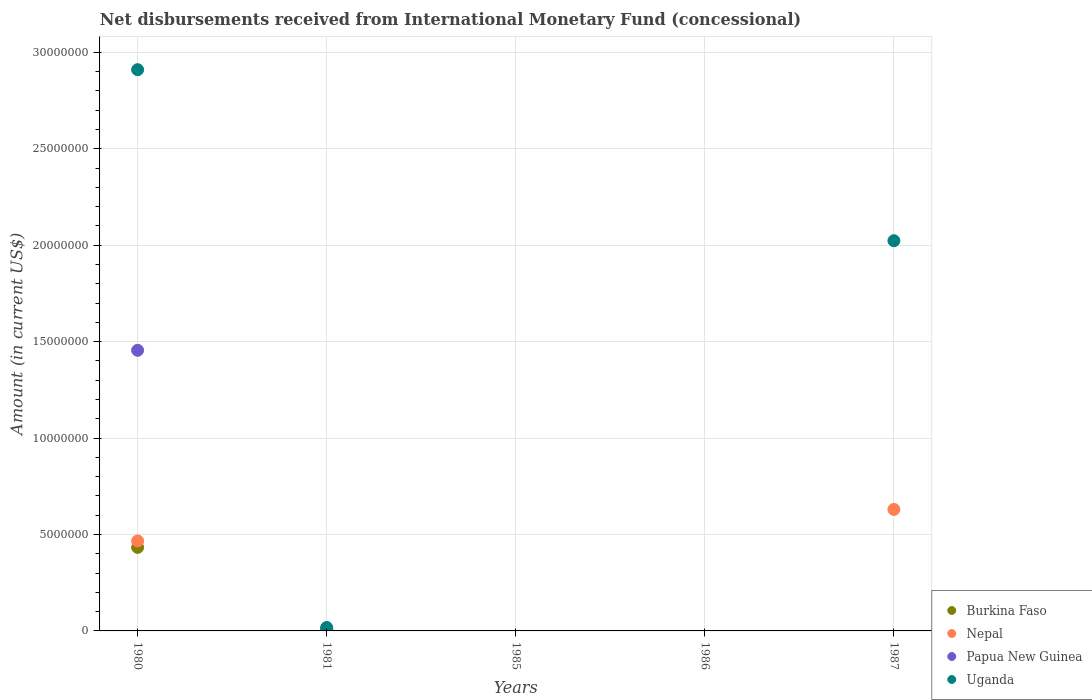Is the number of dotlines equal to the number of legend labels?
Offer a very short reply. No. What is the amount of disbursements received from International Monetary Fund in Uganda in 1981?
Your answer should be very brief. 1.78e+05. Across all years, what is the maximum amount of disbursements received from International Monetary Fund in Uganda?
Offer a very short reply. 2.91e+07. Across all years, what is the minimum amount of disbursements received from International Monetary Fund in Papua New Guinea?
Your answer should be very brief. 0. What is the total amount of disbursements received from International Monetary Fund in Nepal in the graph?
Provide a short and direct response. 1.10e+07. What is the difference between the amount of disbursements received from International Monetary Fund in Papua New Guinea in 1980 and that in 1981?
Offer a very short reply. 1.45e+07. What is the difference between the amount of disbursements received from International Monetary Fund in Papua New Guinea in 1986 and the amount of disbursements received from International Monetary Fund in Nepal in 1987?
Make the answer very short. -6.30e+06. What is the average amount of disbursements received from International Monetary Fund in Burkina Faso per year?
Offer a terse response. 8.78e+05. In the year 1981, what is the difference between the amount of disbursements received from International Monetary Fund in Burkina Faso and amount of disbursements received from International Monetary Fund in Papua New Guinea?
Offer a very short reply. -3.20e+04. What is the ratio of the amount of disbursements received from International Monetary Fund in Nepal in 1980 to that in 1987?
Offer a terse response. 0.74. Is the amount of disbursements received from International Monetary Fund in Uganda in 1980 less than that in 1981?
Ensure brevity in your answer.  No. What is the difference between the highest and the second highest amount of disbursements received from International Monetary Fund in Uganda?
Make the answer very short. 8.87e+06. What is the difference between the highest and the lowest amount of disbursements received from International Monetary Fund in Nepal?
Your response must be concise. 6.30e+06. Is it the case that in every year, the sum of the amount of disbursements received from International Monetary Fund in Nepal and amount of disbursements received from International Monetary Fund in Uganda  is greater than the sum of amount of disbursements received from International Monetary Fund in Burkina Faso and amount of disbursements received from International Monetary Fund in Papua New Guinea?
Your answer should be very brief. No. Does the amount of disbursements received from International Monetary Fund in Nepal monotonically increase over the years?
Your answer should be compact. No. Is the amount of disbursements received from International Monetary Fund in Papua New Guinea strictly greater than the amount of disbursements received from International Monetary Fund in Uganda over the years?
Offer a very short reply. No. Is the amount of disbursements received from International Monetary Fund in Papua New Guinea strictly less than the amount of disbursements received from International Monetary Fund in Nepal over the years?
Make the answer very short. No. How many years are there in the graph?
Offer a very short reply. 5. What is the difference between two consecutive major ticks on the Y-axis?
Provide a succinct answer. 5.00e+06. Does the graph contain any zero values?
Give a very brief answer. Yes. How are the legend labels stacked?
Your answer should be compact. Vertical. What is the title of the graph?
Provide a short and direct response. Net disbursements received from International Monetary Fund (concessional). Does "Cyprus" appear as one of the legend labels in the graph?
Ensure brevity in your answer.  No. What is the label or title of the X-axis?
Provide a short and direct response. Years. What is the Amount (in current US$) in Burkina Faso in 1980?
Offer a very short reply. 4.33e+06. What is the Amount (in current US$) in Nepal in 1980?
Keep it short and to the point. 4.66e+06. What is the Amount (in current US$) in Papua New Guinea in 1980?
Provide a succinct answer. 1.46e+07. What is the Amount (in current US$) of Uganda in 1980?
Offer a very short reply. 2.91e+07. What is the Amount (in current US$) of Burkina Faso in 1981?
Keep it short and to the point. 5.80e+04. What is the Amount (in current US$) of Nepal in 1981?
Your answer should be very brief. 6.30e+04. What is the Amount (in current US$) in Uganda in 1981?
Your answer should be compact. 1.78e+05. What is the Amount (in current US$) of Burkina Faso in 1985?
Your answer should be very brief. 0. What is the Amount (in current US$) in Nepal in 1985?
Your answer should be very brief. 0. What is the Amount (in current US$) of Papua New Guinea in 1985?
Offer a terse response. 0. What is the Amount (in current US$) in Burkina Faso in 1986?
Your answer should be compact. 0. What is the Amount (in current US$) of Nepal in 1986?
Keep it short and to the point. 0. What is the Amount (in current US$) of Nepal in 1987?
Give a very brief answer. 6.30e+06. What is the Amount (in current US$) of Papua New Guinea in 1987?
Your answer should be very brief. 0. What is the Amount (in current US$) in Uganda in 1987?
Keep it short and to the point. 2.02e+07. Across all years, what is the maximum Amount (in current US$) of Burkina Faso?
Offer a very short reply. 4.33e+06. Across all years, what is the maximum Amount (in current US$) in Nepal?
Offer a very short reply. 6.30e+06. Across all years, what is the maximum Amount (in current US$) in Papua New Guinea?
Your answer should be very brief. 1.46e+07. Across all years, what is the maximum Amount (in current US$) of Uganda?
Your response must be concise. 2.91e+07. Across all years, what is the minimum Amount (in current US$) of Burkina Faso?
Keep it short and to the point. 0. Across all years, what is the minimum Amount (in current US$) in Nepal?
Your response must be concise. 0. What is the total Amount (in current US$) in Burkina Faso in the graph?
Keep it short and to the point. 4.39e+06. What is the total Amount (in current US$) in Nepal in the graph?
Provide a short and direct response. 1.10e+07. What is the total Amount (in current US$) of Papua New Guinea in the graph?
Give a very brief answer. 1.46e+07. What is the total Amount (in current US$) of Uganda in the graph?
Offer a terse response. 4.95e+07. What is the difference between the Amount (in current US$) in Burkina Faso in 1980 and that in 1981?
Make the answer very short. 4.27e+06. What is the difference between the Amount (in current US$) in Nepal in 1980 and that in 1981?
Make the answer very short. 4.60e+06. What is the difference between the Amount (in current US$) in Papua New Guinea in 1980 and that in 1981?
Make the answer very short. 1.45e+07. What is the difference between the Amount (in current US$) of Uganda in 1980 and that in 1981?
Give a very brief answer. 2.89e+07. What is the difference between the Amount (in current US$) in Nepal in 1980 and that in 1987?
Provide a short and direct response. -1.64e+06. What is the difference between the Amount (in current US$) of Uganda in 1980 and that in 1987?
Provide a short and direct response. 8.87e+06. What is the difference between the Amount (in current US$) of Nepal in 1981 and that in 1987?
Keep it short and to the point. -6.24e+06. What is the difference between the Amount (in current US$) of Uganda in 1981 and that in 1987?
Offer a very short reply. -2.01e+07. What is the difference between the Amount (in current US$) of Burkina Faso in 1980 and the Amount (in current US$) of Nepal in 1981?
Make the answer very short. 4.27e+06. What is the difference between the Amount (in current US$) in Burkina Faso in 1980 and the Amount (in current US$) in Papua New Guinea in 1981?
Provide a succinct answer. 4.24e+06. What is the difference between the Amount (in current US$) in Burkina Faso in 1980 and the Amount (in current US$) in Uganda in 1981?
Offer a very short reply. 4.15e+06. What is the difference between the Amount (in current US$) in Nepal in 1980 and the Amount (in current US$) in Papua New Guinea in 1981?
Make the answer very short. 4.58e+06. What is the difference between the Amount (in current US$) in Nepal in 1980 and the Amount (in current US$) in Uganda in 1981?
Your response must be concise. 4.49e+06. What is the difference between the Amount (in current US$) in Papua New Guinea in 1980 and the Amount (in current US$) in Uganda in 1981?
Provide a short and direct response. 1.44e+07. What is the difference between the Amount (in current US$) in Burkina Faso in 1980 and the Amount (in current US$) in Nepal in 1987?
Make the answer very short. -1.97e+06. What is the difference between the Amount (in current US$) in Burkina Faso in 1980 and the Amount (in current US$) in Uganda in 1987?
Offer a terse response. -1.59e+07. What is the difference between the Amount (in current US$) in Nepal in 1980 and the Amount (in current US$) in Uganda in 1987?
Ensure brevity in your answer.  -1.56e+07. What is the difference between the Amount (in current US$) in Papua New Guinea in 1980 and the Amount (in current US$) in Uganda in 1987?
Offer a very short reply. -5.68e+06. What is the difference between the Amount (in current US$) in Burkina Faso in 1981 and the Amount (in current US$) in Nepal in 1987?
Your answer should be very brief. -6.24e+06. What is the difference between the Amount (in current US$) of Burkina Faso in 1981 and the Amount (in current US$) of Uganda in 1987?
Give a very brief answer. -2.02e+07. What is the difference between the Amount (in current US$) of Nepal in 1981 and the Amount (in current US$) of Uganda in 1987?
Offer a terse response. -2.02e+07. What is the difference between the Amount (in current US$) in Papua New Guinea in 1981 and the Amount (in current US$) in Uganda in 1987?
Offer a very short reply. -2.01e+07. What is the average Amount (in current US$) of Burkina Faso per year?
Your response must be concise. 8.78e+05. What is the average Amount (in current US$) in Nepal per year?
Ensure brevity in your answer.  2.21e+06. What is the average Amount (in current US$) of Papua New Guinea per year?
Make the answer very short. 2.93e+06. What is the average Amount (in current US$) in Uganda per year?
Keep it short and to the point. 9.90e+06. In the year 1980, what is the difference between the Amount (in current US$) of Burkina Faso and Amount (in current US$) of Nepal?
Ensure brevity in your answer.  -3.33e+05. In the year 1980, what is the difference between the Amount (in current US$) of Burkina Faso and Amount (in current US$) of Papua New Guinea?
Offer a terse response. -1.02e+07. In the year 1980, what is the difference between the Amount (in current US$) of Burkina Faso and Amount (in current US$) of Uganda?
Offer a very short reply. -2.48e+07. In the year 1980, what is the difference between the Amount (in current US$) of Nepal and Amount (in current US$) of Papua New Guinea?
Offer a very short reply. -9.89e+06. In the year 1980, what is the difference between the Amount (in current US$) of Nepal and Amount (in current US$) of Uganda?
Offer a terse response. -2.44e+07. In the year 1980, what is the difference between the Amount (in current US$) of Papua New Guinea and Amount (in current US$) of Uganda?
Your answer should be compact. -1.46e+07. In the year 1981, what is the difference between the Amount (in current US$) of Burkina Faso and Amount (in current US$) of Nepal?
Your answer should be very brief. -5000. In the year 1981, what is the difference between the Amount (in current US$) in Burkina Faso and Amount (in current US$) in Papua New Guinea?
Provide a succinct answer. -3.20e+04. In the year 1981, what is the difference between the Amount (in current US$) of Nepal and Amount (in current US$) of Papua New Guinea?
Offer a terse response. -2.70e+04. In the year 1981, what is the difference between the Amount (in current US$) in Nepal and Amount (in current US$) in Uganda?
Ensure brevity in your answer.  -1.15e+05. In the year 1981, what is the difference between the Amount (in current US$) of Papua New Guinea and Amount (in current US$) of Uganda?
Make the answer very short. -8.80e+04. In the year 1987, what is the difference between the Amount (in current US$) of Nepal and Amount (in current US$) of Uganda?
Offer a terse response. -1.39e+07. What is the ratio of the Amount (in current US$) of Burkina Faso in 1980 to that in 1981?
Your answer should be very brief. 74.69. What is the ratio of the Amount (in current US$) of Nepal in 1980 to that in 1981?
Give a very brief answer. 74.05. What is the ratio of the Amount (in current US$) of Papua New Guinea in 1980 to that in 1981?
Offer a very short reply. 161.69. What is the ratio of the Amount (in current US$) of Uganda in 1980 to that in 1981?
Your response must be concise. 163.5. What is the ratio of the Amount (in current US$) of Nepal in 1980 to that in 1987?
Provide a succinct answer. 0.74. What is the ratio of the Amount (in current US$) of Uganda in 1980 to that in 1987?
Make the answer very short. 1.44. What is the ratio of the Amount (in current US$) of Uganda in 1981 to that in 1987?
Provide a short and direct response. 0.01. What is the difference between the highest and the second highest Amount (in current US$) of Nepal?
Keep it short and to the point. 1.64e+06. What is the difference between the highest and the second highest Amount (in current US$) of Uganda?
Your answer should be very brief. 8.87e+06. What is the difference between the highest and the lowest Amount (in current US$) of Burkina Faso?
Ensure brevity in your answer.  4.33e+06. What is the difference between the highest and the lowest Amount (in current US$) of Nepal?
Provide a short and direct response. 6.30e+06. What is the difference between the highest and the lowest Amount (in current US$) in Papua New Guinea?
Your answer should be very brief. 1.46e+07. What is the difference between the highest and the lowest Amount (in current US$) of Uganda?
Make the answer very short. 2.91e+07. 